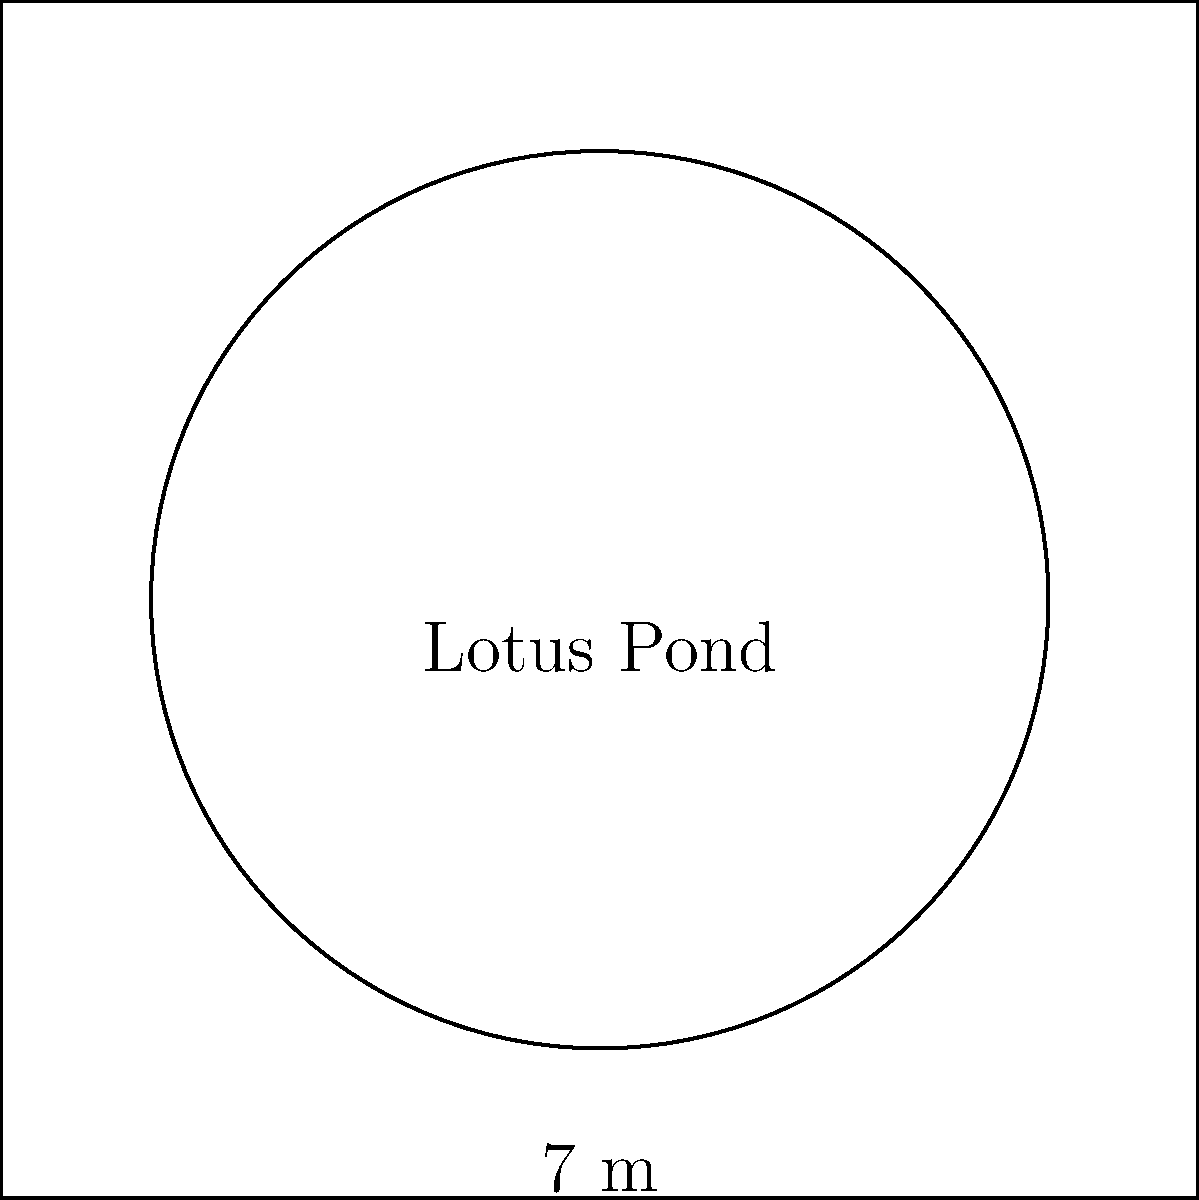A circular lotus pond, a common feature in Khmer architecture, has a diameter of 7 meters. Calculate the area of this pond in square meters. Round your answer to two decimal places. To find the area of the circular lotus pond, we'll follow these steps:

1) The formula for the area of a circle is:
   $$A = \pi r^2$$
   where $A$ is the area and $r$ is the radius.

2) We're given the diameter, which is 7 meters. The radius is half of the diameter:
   $$r = \frac{7}{2} = 3.5 \text{ meters}$$

3) Now we can substitute this into our formula:
   $$A = \pi (3.5)^2$$

4) Let's calculate:
   $$A = \pi \times 12.25 \approx 38.4845 \text{ square meters}$$

5) Rounding to two decimal places:
   $$A \approx 38.48 \text{ square meters}$$
Answer: $38.48 \text{ m}^2$ 